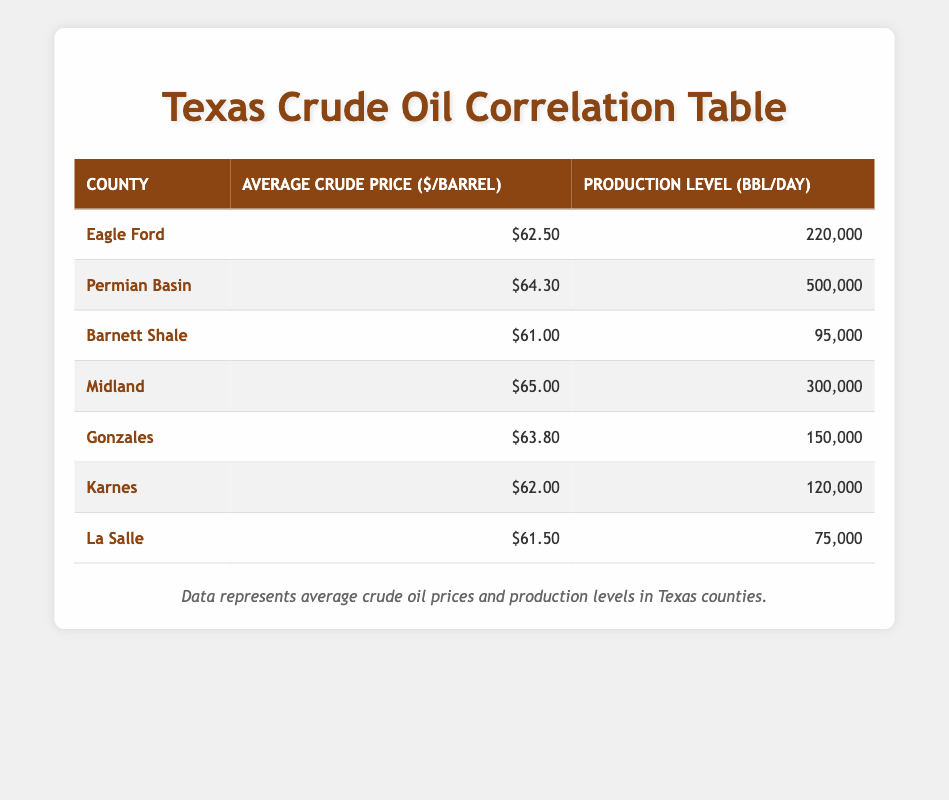What is the average crude price per barrel for the Eagle Ford county? The table shows the average crude price for Eagle Ford, which is directly listed as 62.50.
Answer: 62.50 Which county has the highest production level? By examining the production levels in the table, I find that the Permian Basin has the highest production level at 500,000 barrels per day.
Answer: Permian Basin What is the combined production level of Barnett Shale and La Salle counties? To find the combined production, I add Barnett Shale's production level of 95,000 and La Salle's production of 75,000, resulting in 95,000 + 75,000 = 170,000.
Answer: 170,000 Is the average crude price in Gonzales greater than that in Karnes? Comparing the average prices, Gonzales is listed at 63.80 and Karnes at 62.00. Since 63.80 is greater than 62.00, the statement is true.
Answer: Yes What is the difference in average crude prices between the county with the highest and lowest production levels? The Permian Basin has the highest production level at 500,000 and an average price of 64.30. La Salle has the lowest production level at 75,000 with an average price of 61.50. The difference in prices is 64.30 - 61.50 = 2.80.
Answer: 2.80 How many counties have an average crude price above 62.00? By examining the prices, I see that the counties with average prices above 62.00 are Permian Basin (64.30), Midland (65.00), Gonzales (63.80), and Eagle Ford (62.50). This totals 4 counties.
Answer: 4 What is the average production level across all listed counties? To find the average production level, I sum all production values: 220,000 + 500,000 + 95,000 + 300,000 + 150,000 + 120,000 + 75,000 = 1,460,000. Dividing by the number of counties (7), the average production level is 1,460,000 / 7 ≈ 208,571.
Answer: 208,571 Which county has both a higher crude price and production level compared to La Salle? La Salle has a price of 61.50 and a production level of 75,000. Midland, with a price of 65.00 and production of 300,000, meets both criteria.
Answer: Midland 